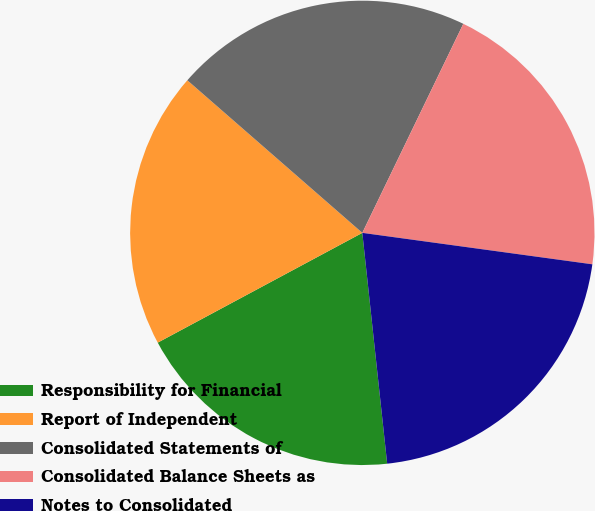Convert chart. <chart><loc_0><loc_0><loc_500><loc_500><pie_chart><fcel>Responsibility for Financial<fcel>Report of Independent<fcel>Consolidated Statements of<fcel>Consolidated Balance Sheets as<fcel>Notes to Consolidated<nl><fcel>18.87%<fcel>19.25%<fcel>20.75%<fcel>20.0%<fcel>21.13%<nl></chart> 